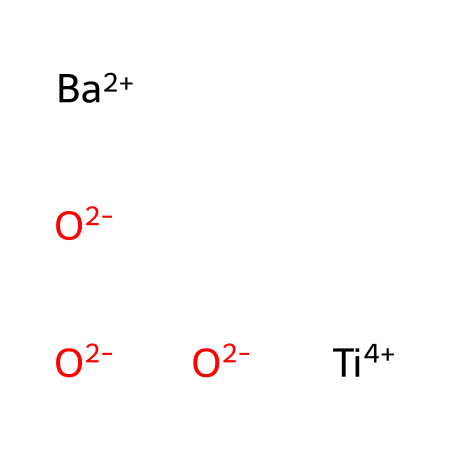What is the main cation in this chemical? The main cation can be identified by looking for positively charged species in the SMILES representation. In this case, the barium ion is present as [Ba+2], indicating that barium is the main cation.
Answer: barium How many oxygen atoms are present in the structure? To determine the number of oxygen atoms, count the occurrences of the oxygen atoms represented by [O-2] in the SMILES. There are three instances of [O-2], indicating there are three oxygen atoms.
Answer: three What is the oxidation state of titanium in this compound? The oxidation state of titanium can be inferred from the notation [Ti+4] in the SMILES representation, which indicates that titanium has a charge of +4.
Answer: +4 What type of bonding is primarily present in barium titanate? Barium titanate primarily exhibits ionic bonding due to the interaction between the barium cation and the titanium oxide framework, as well as covalent characteristics involving the titanium and oxygen atoms.
Answer: ionic How does the presence of barium influence the properties of this piezoelectric sensor? Barium, being a large cation, contributes to the structural stability and polarization characteristics of barium titanate, enhancing its piezoelectric properties and making it suitable for sensors.
Answer: enhances stability What role do the oxygen atoms play in the structure of barium titanate? The oxygen atoms are integral to the crystalline structure of barium titanate and participate in bonding with titanium, which is essential for the material's piezoelectric properties.
Answer: structural integrity What is the overall charge of the chemical compound represented? In the SMILES representation, the positive charge from barium (+2) and titanium (+4) and the negative charge from three oxygen atoms (-6) combine to give an overall charge of zero, indicating that the compound is neutral.
Answer: zero 